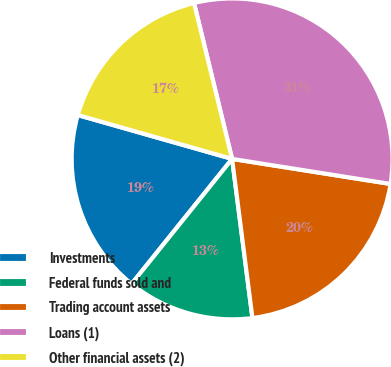<chart> <loc_0><loc_0><loc_500><loc_500><pie_chart><fcel>Investments<fcel>Federal funds sold and<fcel>Trading account assets<fcel>Loans (1)<fcel>Other financial assets (2)<nl><fcel>18.63%<fcel>12.8%<fcel>20.48%<fcel>31.31%<fcel>16.78%<nl></chart> 